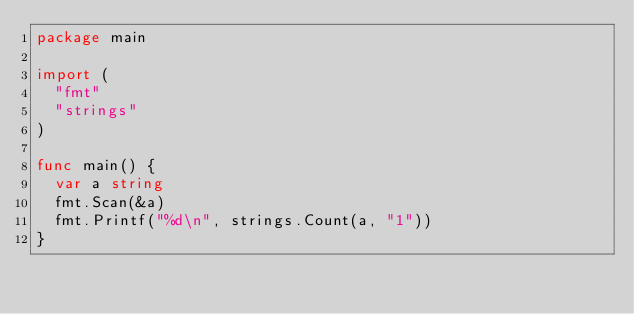Convert code to text. <code><loc_0><loc_0><loc_500><loc_500><_Go_>package main

import (
	"fmt"
	"strings"
)

func main() {
	var a string
	fmt.Scan(&a)
	fmt.Printf("%d\n", strings.Count(a, "1"))
}
</code> 